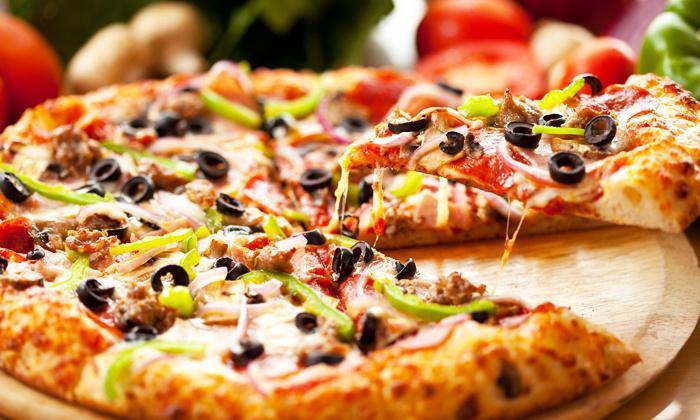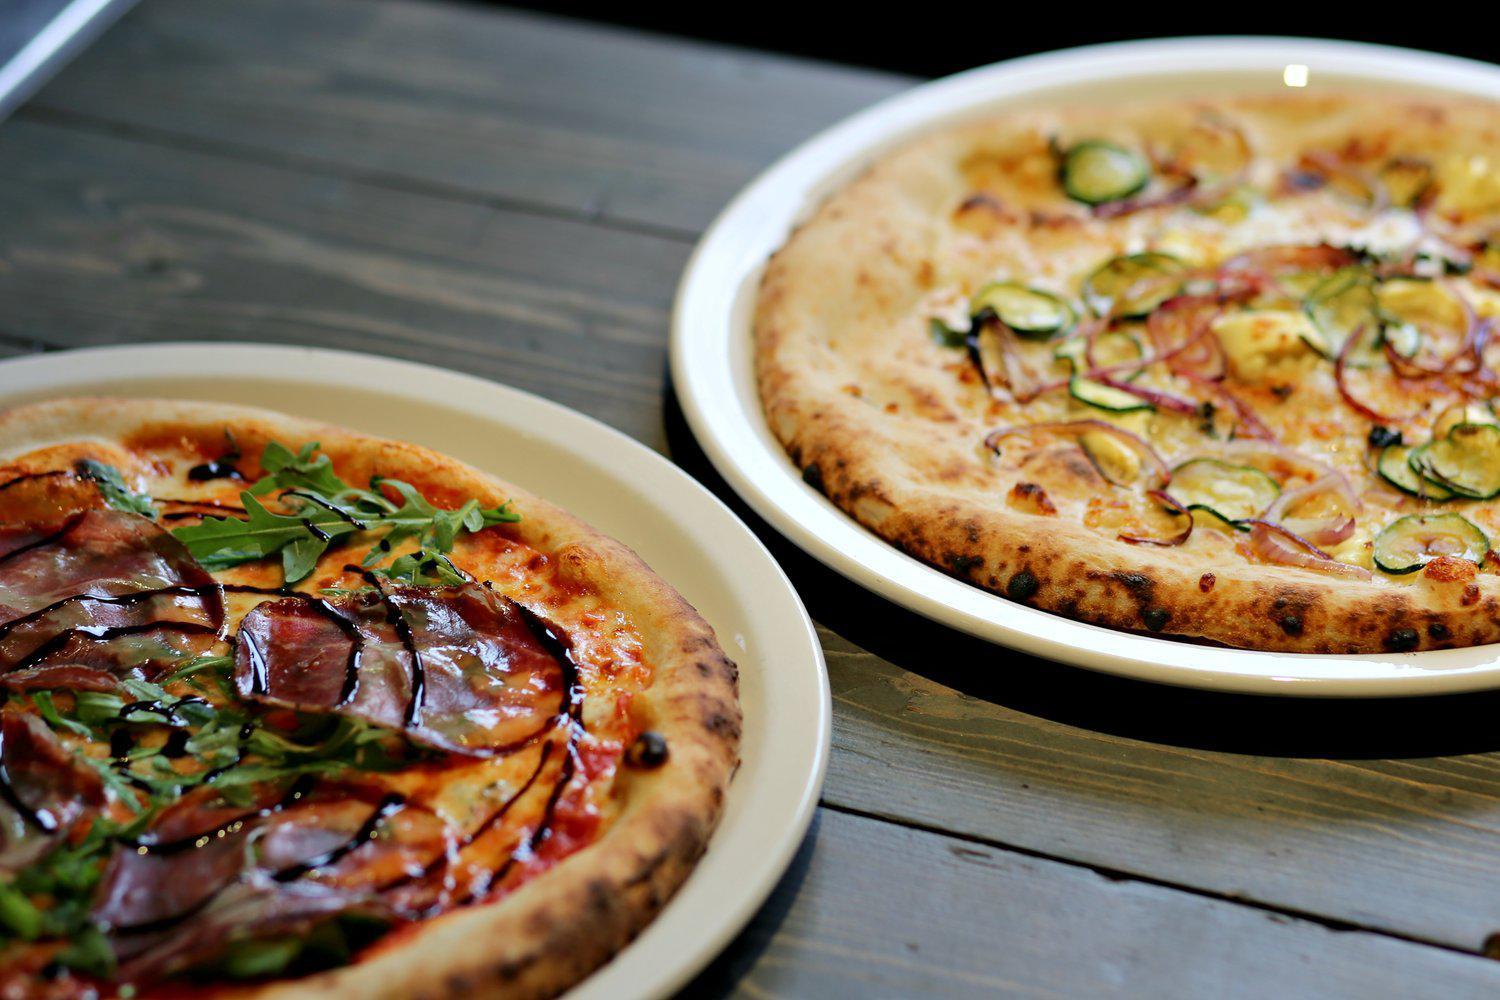The first image is the image on the left, the second image is the image on the right. Assess this claim about the two images: "Exactly one pizza has green peppers on it.". Correct or not? Answer yes or no. Yes. The first image is the image on the left, the second image is the image on the right. For the images shown, is this caption "The left image shows one round sliced pizza with a single slice out of place, and the right image contains more than one plate of food, including a pizza with green slices on top." true? Answer yes or no. Yes. 